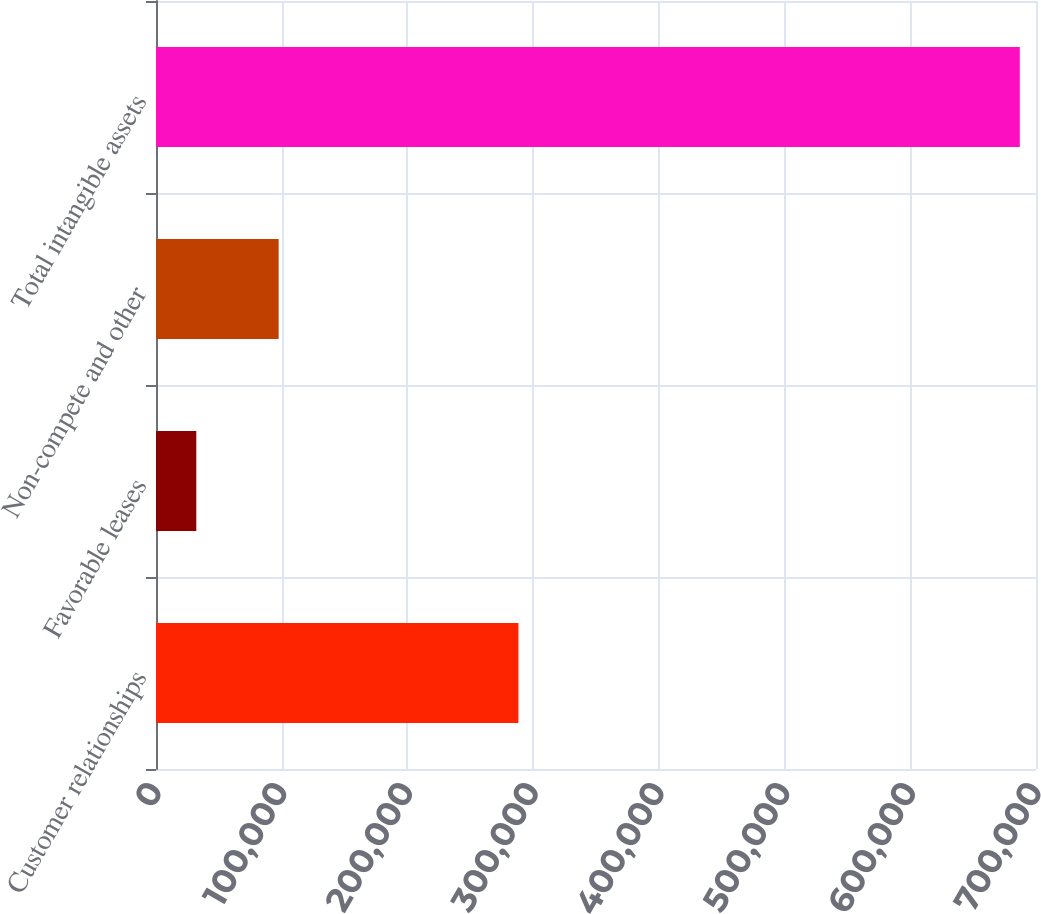Convert chart to OTSL. <chart><loc_0><loc_0><loc_500><loc_500><bar_chart><fcel>Customer relationships<fcel>Favorable leases<fcel>Non-compete and other<fcel>Total intangible assets<nl><fcel>288288<fcel>32056<fcel>97562.9<fcel>687125<nl></chart> 